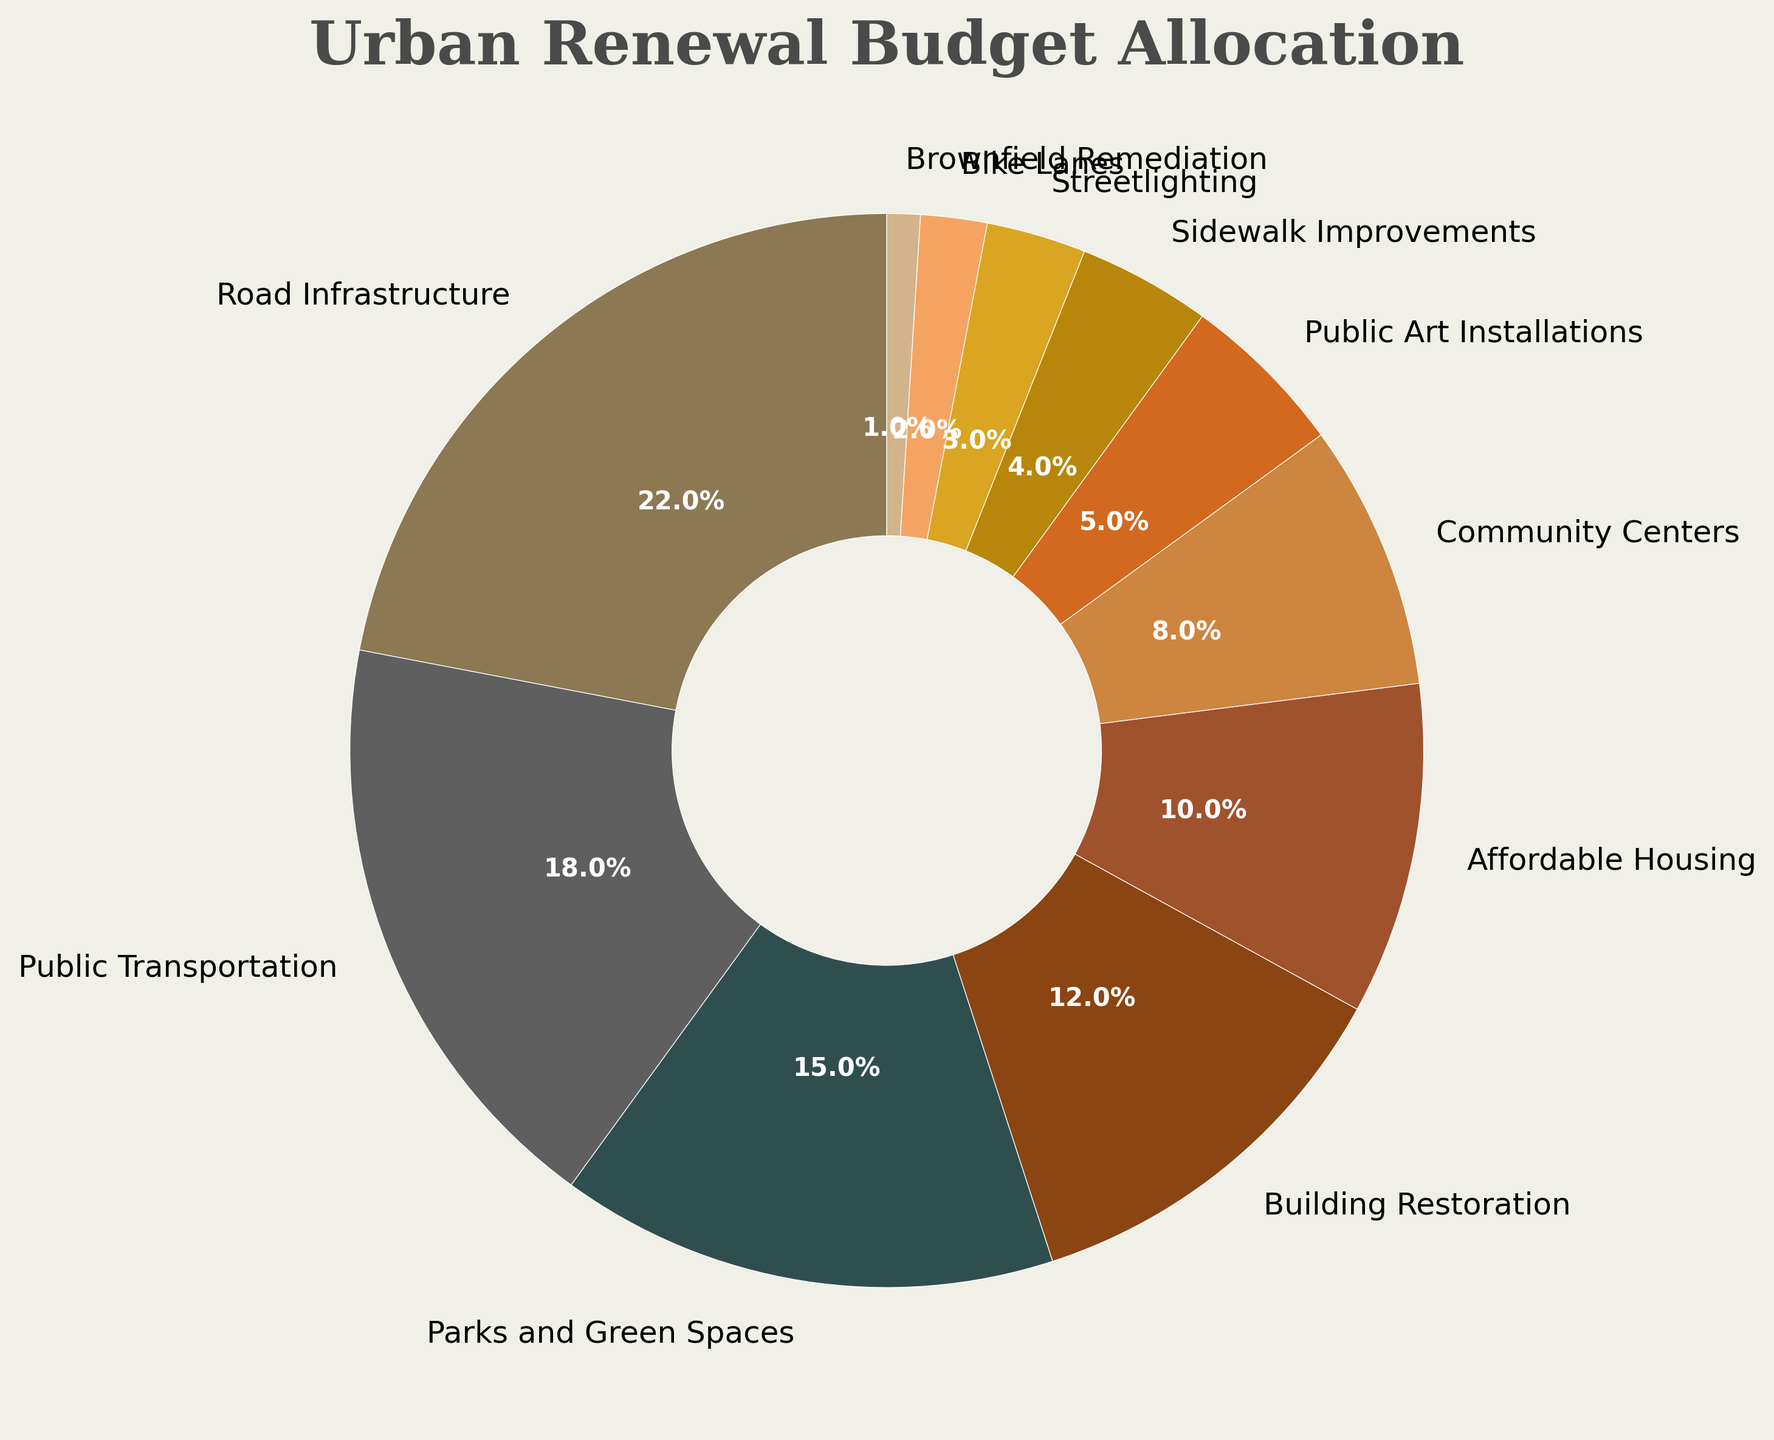What percentage of the budget is allocated to Road Infrastructure and Public Transportation together? To find the total percentage allocated to Road Infrastructure and Public Transportation, we sum their individual percentages: 22% (Road Infrastructure) + 18% (Public Transportation) = 40%.
Answer: 40% Which project has the smallest allocation of the budget? By examining the pie chart, we observe that Brownfield Remediation has the smallest allocated budget at 1%.
Answer: Brownfield Remediation How much more budget percentage is allocated to Parks and Green Spaces compared to Streetlighting? First, identify the percentage allocated to each: Parks and Green Spaces (15%) and Streetlighting (3%). Then, subtract the smaller percentage from the larger one: 15% - 3% = 12%.
Answer: 12% What is the combined budget percentage for Affordable Housing and Community Centers? Sum the percentages for Affordable Housing and Community Centers: 10% (Affordable Housing) + 8% (Community Centers) = 18%.
Answer: 18% Which project, Building Restoration or Public Art Installations, has a greater share of the budget? Compare the percentages: Building Restoration has 12% and Public Art Installations has 5%. Therefore, Building Restoration has a greater share.
Answer: Building Restoration What is the percentage difference between the budget allocation for Bike Lanes and Sidewalk Improvements? First, note the percentages: Bike Lanes (2%) and Sidewalk Improvements (4%). Then, calculate the difference: 4% - 2% = 2%.
Answer: 2% Identify the project with the third-largest budget allocation and state its percentage. From the pie chart, the projects with the largest allocations are Road Infrastructure (22%), Public Transportation (18%), and Parks and Green Spaces (15%). Thus, Parks and Green Spaces is the third-largest with 15%.
Answer: Parks and Green Spaces, 15% Which projects have a budget allocation of less than 5%? By examining the pie chart, the projects with allocations less than 5% are Sidewalk Improvements (4%), Streetlighting (3%), Bike Lanes (2%), and Brownfield Remediation (1%).
Answer: Sidewalk Improvements, Streetlighting, Bike Lanes, Brownfield Remediation Rank the top four projects by their budget allocation from highest to lowest. From the pie chart, the top four projects by budget allocation are: Road Infrastructure (22%), Public Transportation (18%), Parks and Green Spaces (15%), and Building Restoration (12%).
Answer: Road Infrastructure, Public Transportation, Parks and Green Spaces, Building Restoration Which color is used to represent Affordable Housing, and what is its percentage in the budget allocation? The pie chart uses a specific color pattern. Affordable Housing is represented by a darker shade of brown and has 10% of the budget allocation.
Answer: Darker shade of brown, 10% 